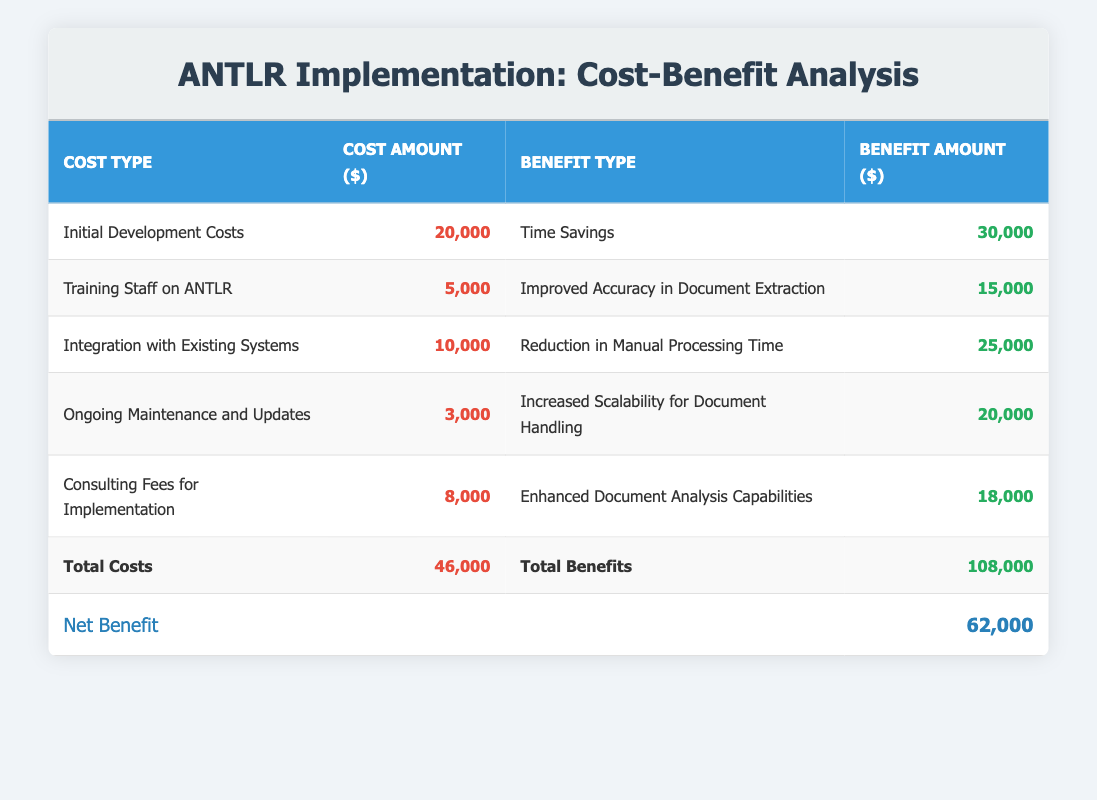What is the total amount of initial development costs? The table indicates that the initial development costs amount to $20,000.
Answer: 20,000 What is the benefit amount associated with improved accuracy in document extraction? The benefit amount for improved accuracy in document extraction is listed as $15,000 in the table.
Answer: 15,000 How much do ongoing maintenance and updates cost compared to the benefits from increased scalability for document handling? The cost of ongoing maintenance and updates is $3,000 and the benefit from increased scalability for document handling is $20,000. Therefore, the benefits greatly exceed the costs.
Answer: Costs: 3,000; Benefits: 20,000 What is the net benefit of implementing ANTLR? The net benefit is the total benefits amount ($108,000) minus the total costs amount ($46,000), resulting in a net benefit of $62,000.
Answer: 62,000 Is the total benefits amount greater than twice the total costs amount? The total benefits amount is $108,000, while twice the total costs ($46,000) is $92,000. Since $108,000 is greater than $92,000, the statement is true.
Answer: Yes How much more do the benefits from reduction in manual processing time exceed the costs of integration with existing systems? Benefits from reduction in manual processing time are $25,000, and the costs of integration with existing systems are $10,000. The difference is $25,000 - $10,000 = $15,000.
Answer: 15,000 What are the total costs and total benefits according to the table? The table displays total costs of $46,000 and total benefits of $108,000. These values are summed from the individual costs and benefits listed in the rows of the table.
Answer: Total Costs: 46,000; Total Benefits: 108,000 Do consultation fees contribute a larger benefit than the cost for training staff on ANTLR? Consultation fees amount to $8,000 with benefits of $18,000, while training costs $5,000 with benefits of $15,000. Since $18,000 is greater than $8,000 for consultation fees and $15,000 is greater than $5,000 for training, the consultation fees do offer a larger margin.
Answer: Yes 